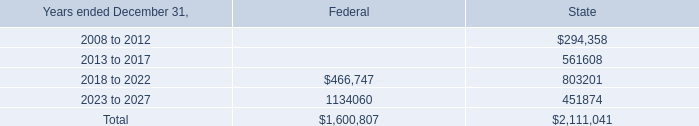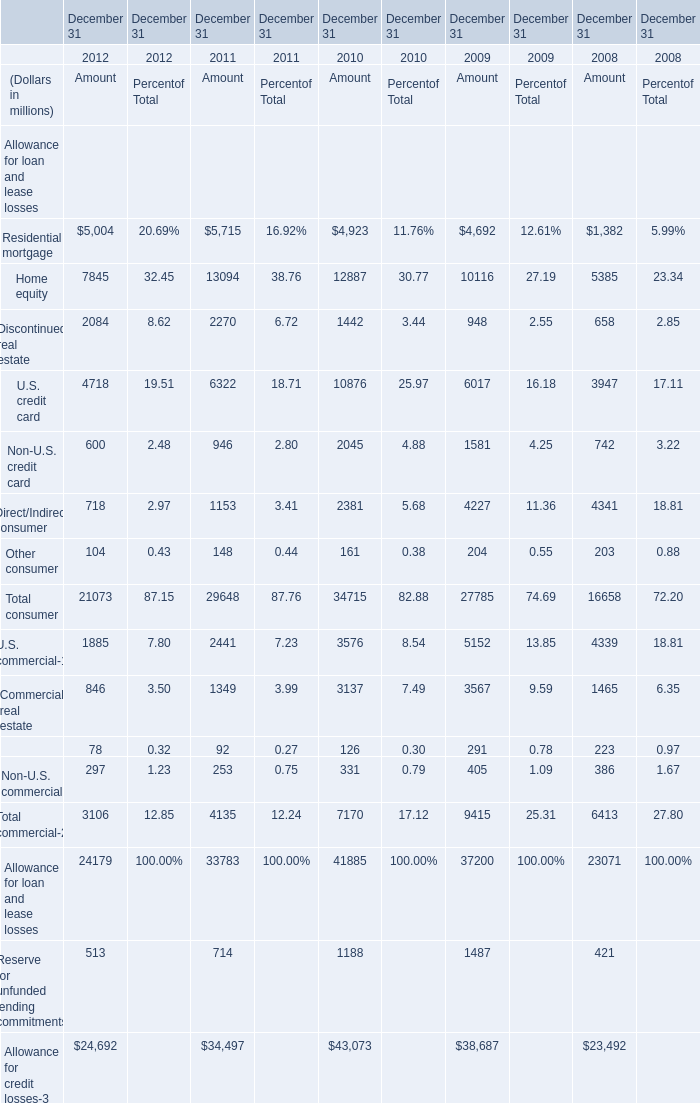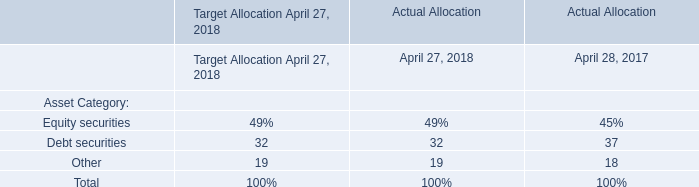What's the growth rate of Home equity for Amout in 2011? 
Computations: ((13094 - 12887) / 12887)
Answer: 0.01606. what is the change in balance of unrecognized tax benefits during 2007? 
Computations: (59.2 - 183.9)
Answer: -124.7. 